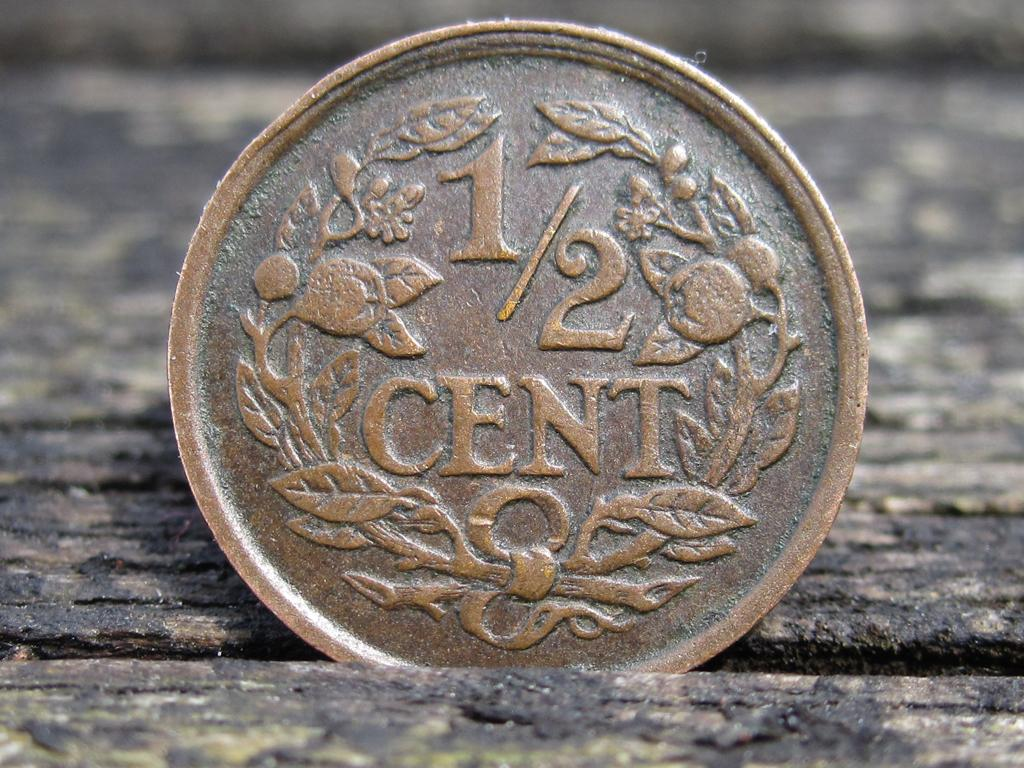Provide a one-sentence caption for the provided image. An old coin worth half a cent sits in a crack between wood planks. 